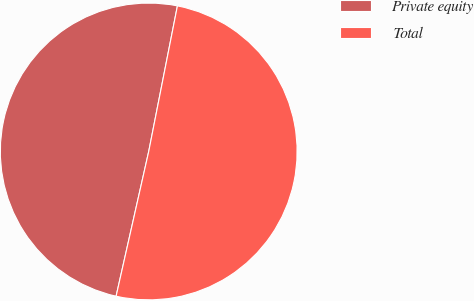Convert chart. <chart><loc_0><loc_0><loc_500><loc_500><pie_chart><fcel>Private equity<fcel>Total<nl><fcel>49.57%<fcel>50.43%<nl></chart> 